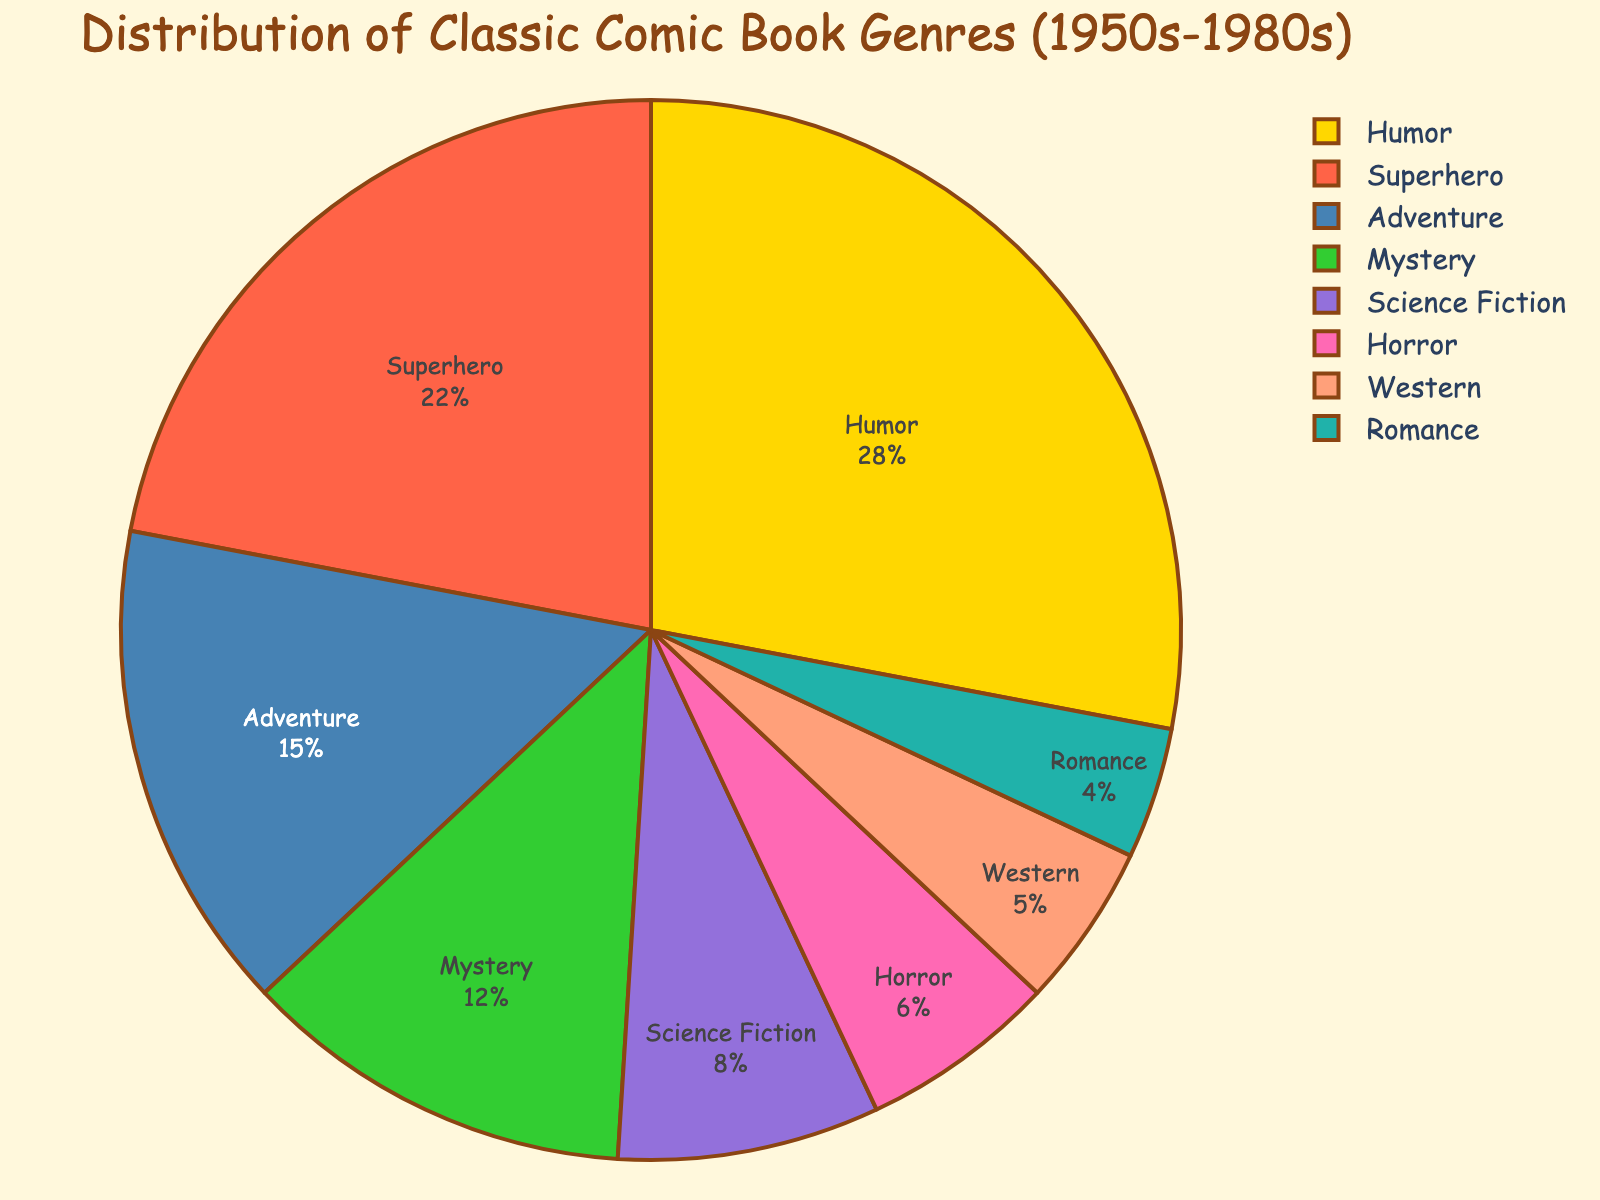What's the most common comic book genre from the 1950s-1980s? The pie chart shows the distribution of different comic book genres. The segment with the largest percentage represents the most common genre. Here, the largest segment is Humor with 28%.
Answer: Humor What percentage of comic book genres are either Mystery or Science Fiction from the 1950s-1980s? To find this, add the percentages of Mystery and Science Fiction genres. According to the chart, Mystery is 12% and Science Fiction is 8%. So, 12% + 8% = 20%.
Answer: 20% Is the percentage of Horror comics greater than the percentage of Western comics? The pie chart shows that Horror comics make up 6% while Western comics make up 5%. Since 6% is greater than 5%, Horror comics are more prevalent than Western comics.
Answer: Yes What is the difference in percentage between Superhero and Romance comics? To find the difference, subtract the percentage of Romance comics from Superhero comics. Superhero comics are 22% and Romance comics are 4%. So, 22% - 4% = 18%.
Answer: 18% Which genre has the third highest percentage in the distribution? The pie chart shows that the highest percentages are Humor (28%), followed by Superhero (22%). The third highest is Adventure with 15%.
Answer: Adventure What combined percentage do the lesser-known genres (defined as those with less than 10% each) make up of the total comic book genres? According to the pie chart, Mystery (12%), Science Fiction (8%), Horror (6%), Western (5%), and Romance (4%) individually have either less than 10%. Adding these gives us 8% + 6% + 5% + 4% = 23%.
Answer: 23% Are the percentages of Adventure and Mystery comics equal? The pie chart shows that Adventure comics make up 15%, while Mystery comics make up 12%. These percentages are not equal.
Answer: No What is the least represented comic book genre from the 1950s-1980s? The pie chart shows that Romance has the smallest segment with 4%, making it the least represented genre.
Answer: Romance What is the total percentage of comics that are not categorized as Humor or Superhero? To find this, subtract the combined percentage of Humor (28%) and Superhero (22%) from 100%. So, 100% - (28% + 22%) = 100% - 50% = 50%.
Answer: 50% If you combine the percentages of Adventure and Western comics, does it exceed Humor comics? The pie chart shows Adventure comics at 15% and Western comics at 5%. Adding these gives 15% + 5% = 20%. Since Humor comics are 28%, 20% does not exceed 28%.
Answer: No 